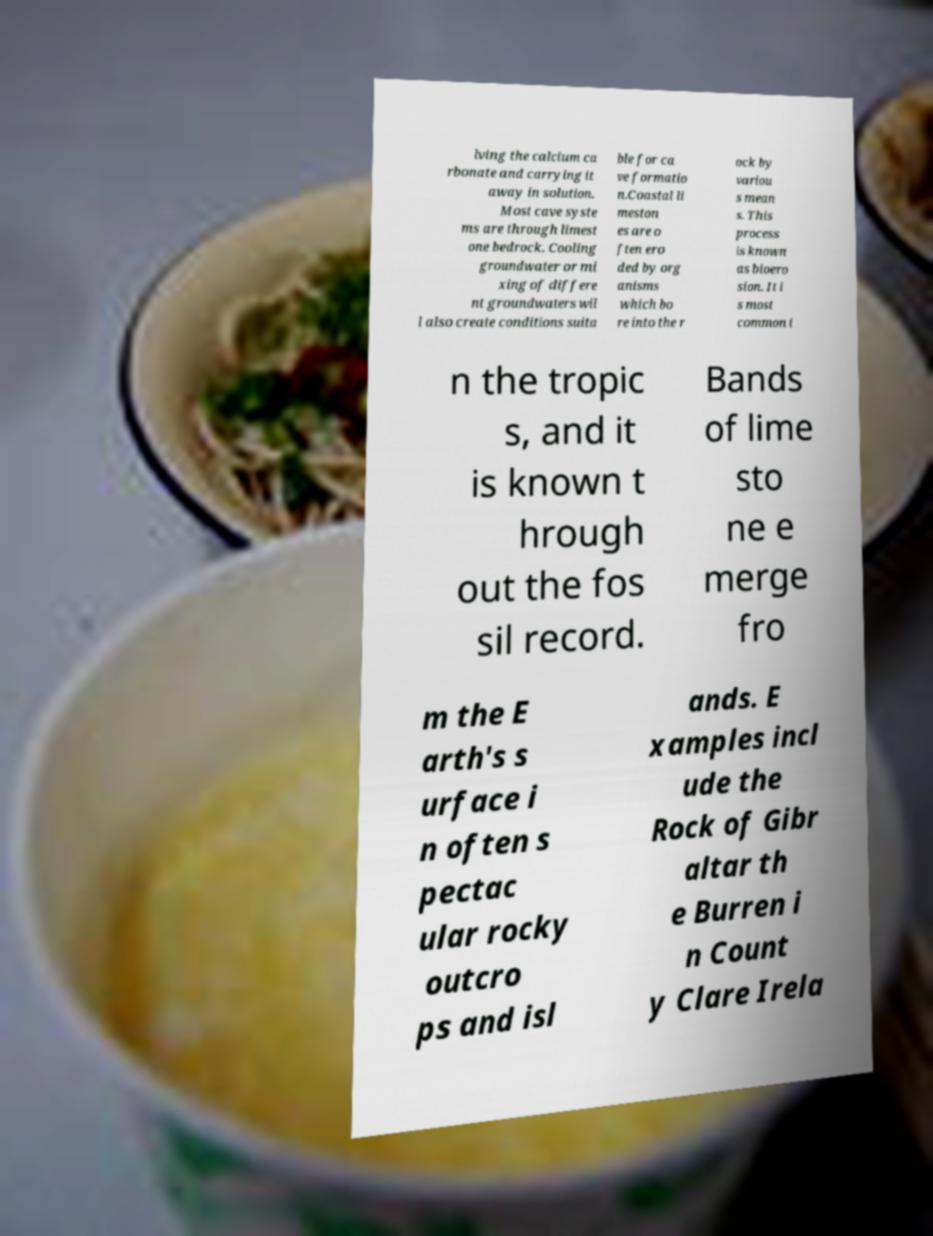What messages or text are displayed in this image? I need them in a readable, typed format. lving the calcium ca rbonate and carrying it away in solution. Most cave syste ms are through limest one bedrock. Cooling groundwater or mi xing of differe nt groundwaters wil l also create conditions suita ble for ca ve formatio n.Coastal li meston es are o ften ero ded by org anisms which bo re into the r ock by variou s mean s. This process is known as bioero sion. It i s most common i n the tropic s, and it is known t hrough out the fos sil record. Bands of lime sto ne e merge fro m the E arth's s urface i n often s pectac ular rocky outcro ps and isl ands. E xamples incl ude the Rock of Gibr altar th e Burren i n Count y Clare Irela 